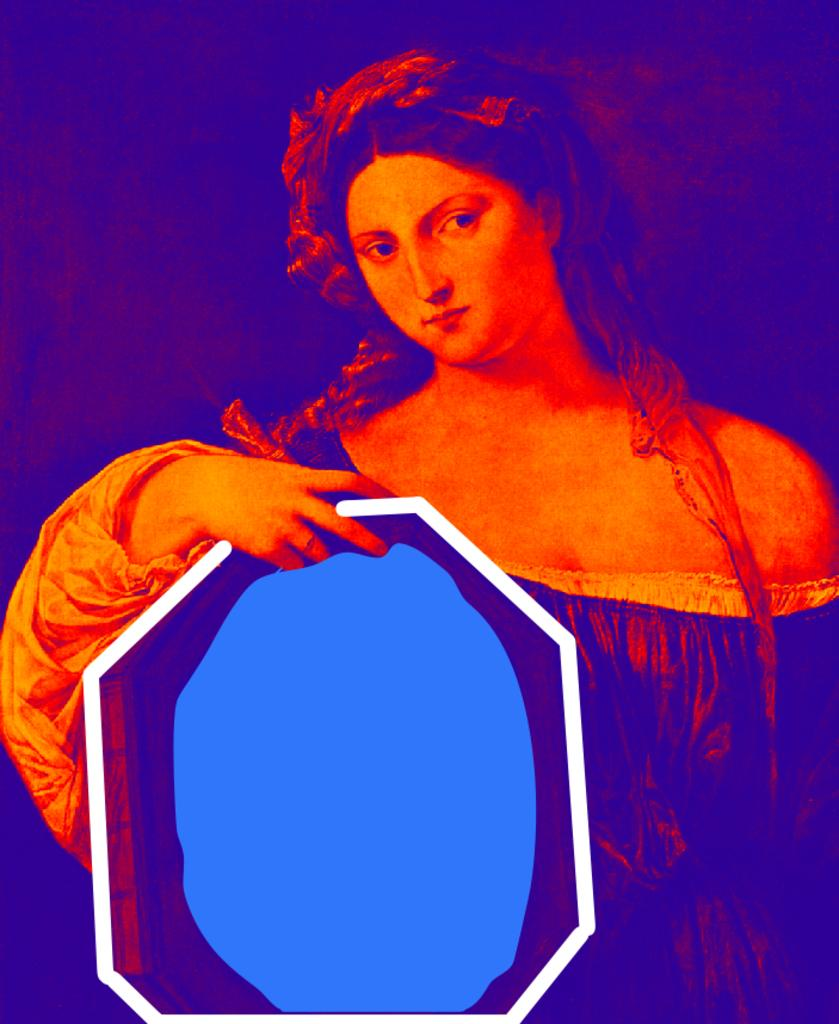What is the main subject of the image? The main subject of the image is a woman. What is the woman holding in her hand? The woman is holding an object in her hand. What type of note is the monkey holding in the image? There is no monkey or note present in the image. The image only features a woman holding an object in her hand. 